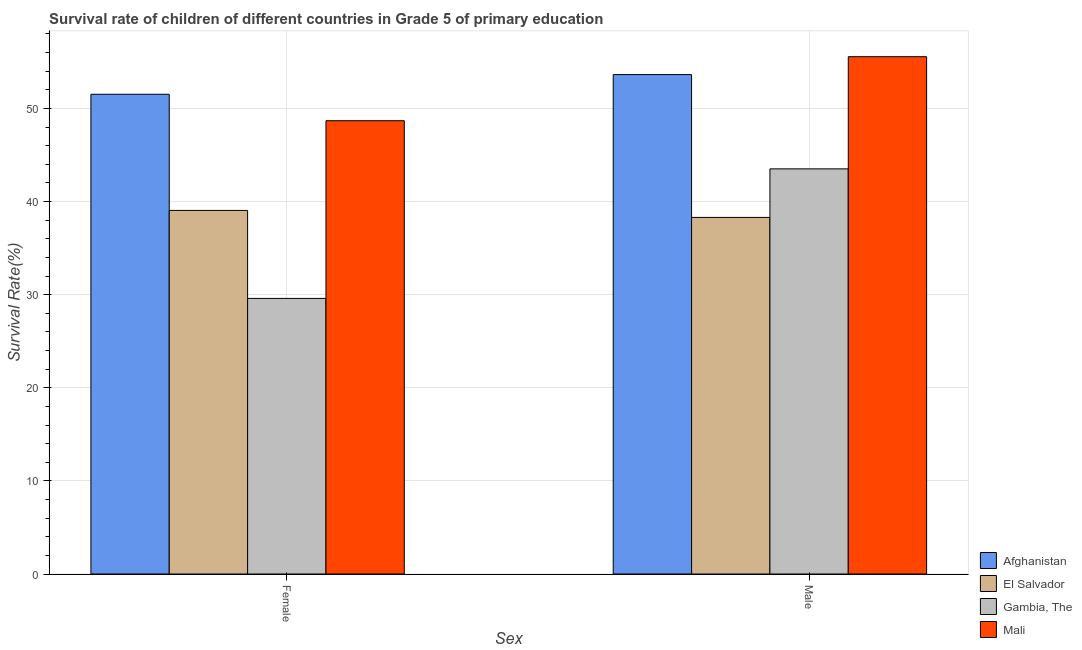Are the number of bars per tick equal to the number of legend labels?
Offer a terse response. Yes. Are the number of bars on each tick of the X-axis equal?
Keep it short and to the point. Yes. How many bars are there on the 2nd tick from the left?
Your answer should be very brief. 4. How many bars are there on the 2nd tick from the right?
Your answer should be very brief. 4. What is the survival rate of female students in primary education in Gambia, The?
Provide a short and direct response. 29.6. Across all countries, what is the maximum survival rate of female students in primary education?
Your answer should be very brief. 51.52. Across all countries, what is the minimum survival rate of female students in primary education?
Ensure brevity in your answer.  29.6. In which country was the survival rate of male students in primary education maximum?
Your answer should be very brief. Mali. In which country was the survival rate of male students in primary education minimum?
Provide a succinct answer. El Salvador. What is the total survival rate of male students in primary education in the graph?
Provide a short and direct response. 190.99. What is the difference between the survival rate of male students in primary education in El Salvador and that in Gambia, The?
Provide a succinct answer. -5.21. What is the difference between the survival rate of male students in primary education in El Salvador and the survival rate of female students in primary education in Gambia, The?
Your answer should be compact. 8.7. What is the average survival rate of male students in primary education per country?
Offer a terse response. 47.75. What is the difference between the survival rate of female students in primary education and survival rate of male students in primary education in Afghanistan?
Make the answer very short. -2.12. In how many countries, is the survival rate of female students in primary education greater than 6 %?
Offer a very short reply. 4. What is the ratio of the survival rate of male students in primary education in El Salvador to that in Afghanistan?
Your answer should be very brief. 0.71. Is the survival rate of female students in primary education in Afghanistan less than that in Gambia, The?
Provide a succinct answer. No. In how many countries, is the survival rate of male students in primary education greater than the average survival rate of male students in primary education taken over all countries?
Your answer should be compact. 2. What does the 2nd bar from the left in Female represents?
Provide a short and direct response. El Salvador. What does the 1st bar from the right in Female represents?
Offer a terse response. Mali. How many countries are there in the graph?
Keep it short and to the point. 4. How many legend labels are there?
Give a very brief answer. 4. How are the legend labels stacked?
Provide a short and direct response. Vertical. What is the title of the graph?
Offer a terse response. Survival rate of children of different countries in Grade 5 of primary education. What is the label or title of the X-axis?
Provide a short and direct response. Sex. What is the label or title of the Y-axis?
Provide a succinct answer. Survival Rate(%). What is the Survival Rate(%) in Afghanistan in Female?
Provide a short and direct response. 51.52. What is the Survival Rate(%) of El Salvador in Female?
Your response must be concise. 39.04. What is the Survival Rate(%) in Gambia, The in Female?
Make the answer very short. 29.6. What is the Survival Rate(%) of Mali in Female?
Give a very brief answer. 48.68. What is the Survival Rate(%) in Afghanistan in Male?
Your answer should be compact. 53.63. What is the Survival Rate(%) of El Salvador in Male?
Offer a very short reply. 38.29. What is the Survival Rate(%) of Gambia, The in Male?
Ensure brevity in your answer.  43.51. What is the Survival Rate(%) in Mali in Male?
Your answer should be very brief. 55.55. Across all Sex, what is the maximum Survival Rate(%) in Afghanistan?
Your response must be concise. 53.63. Across all Sex, what is the maximum Survival Rate(%) of El Salvador?
Your answer should be compact. 39.04. Across all Sex, what is the maximum Survival Rate(%) of Gambia, The?
Ensure brevity in your answer.  43.51. Across all Sex, what is the maximum Survival Rate(%) of Mali?
Offer a very short reply. 55.55. Across all Sex, what is the minimum Survival Rate(%) in Afghanistan?
Provide a succinct answer. 51.52. Across all Sex, what is the minimum Survival Rate(%) in El Salvador?
Your response must be concise. 38.29. Across all Sex, what is the minimum Survival Rate(%) in Gambia, The?
Give a very brief answer. 29.6. Across all Sex, what is the minimum Survival Rate(%) in Mali?
Your response must be concise. 48.68. What is the total Survival Rate(%) in Afghanistan in the graph?
Give a very brief answer. 105.15. What is the total Survival Rate(%) of El Salvador in the graph?
Give a very brief answer. 77.34. What is the total Survival Rate(%) of Gambia, The in the graph?
Keep it short and to the point. 73.1. What is the total Survival Rate(%) of Mali in the graph?
Provide a succinct answer. 104.23. What is the difference between the Survival Rate(%) of Afghanistan in Female and that in Male?
Provide a short and direct response. -2.12. What is the difference between the Survival Rate(%) of El Salvador in Female and that in Male?
Keep it short and to the point. 0.75. What is the difference between the Survival Rate(%) of Gambia, The in Female and that in Male?
Give a very brief answer. -13.91. What is the difference between the Survival Rate(%) of Mali in Female and that in Male?
Provide a short and direct response. -6.88. What is the difference between the Survival Rate(%) in Afghanistan in Female and the Survival Rate(%) in El Salvador in Male?
Keep it short and to the point. 13.22. What is the difference between the Survival Rate(%) of Afghanistan in Female and the Survival Rate(%) of Gambia, The in Male?
Ensure brevity in your answer.  8.01. What is the difference between the Survival Rate(%) in Afghanistan in Female and the Survival Rate(%) in Mali in Male?
Your answer should be very brief. -4.04. What is the difference between the Survival Rate(%) of El Salvador in Female and the Survival Rate(%) of Gambia, The in Male?
Make the answer very short. -4.46. What is the difference between the Survival Rate(%) of El Salvador in Female and the Survival Rate(%) of Mali in Male?
Make the answer very short. -16.51. What is the difference between the Survival Rate(%) in Gambia, The in Female and the Survival Rate(%) in Mali in Male?
Offer a very short reply. -25.96. What is the average Survival Rate(%) of Afghanistan per Sex?
Provide a short and direct response. 52.58. What is the average Survival Rate(%) of El Salvador per Sex?
Your response must be concise. 38.67. What is the average Survival Rate(%) in Gambia, The per Sex?
Your answer should be compact. 36.55. What is the average Survival Rate(%) in Mali per Sex?
Give a very brief answer. 52.12. What is the difference between the Survival Rate(%) of Afghanistan and Survival Rate(%) of El Salvador in Female?
Ensure brevity in your answer.  12.47. What is the difference between the Survival Rate(%) in Afghanistan and Survival Rate(%) in Gambia, The in Female?
Your answer should be compact. 21.92. What is the difference between the Survival Rate(%) in Afghanistan and Survival Rate(%) in Mali in Female?
Your response must be concise. 2.84. What is the difference between the Survival Rate(%) in El Salvador and Survival Rate(%) in Gambia, The in Female?
Your response must be concise. 9.45. What is the difference between the Survival Rate(%) in El Salvador and Survival Rate(%) in Mali in Female?
Your response must be concise. -9.63. What is the difference between the Survival Rate(%) in Gambia, The and Survival Rate(%) in Mali in Female?
Your answer should be very brief. -19.08. What is the difference between the Survival Rate(%) of Afghanistan and Survival Rate(%) of El Salvador in Male?
Offer a very short reply. 15.34. What is the difference between the Survival Rate(%) of Afghanistan and Survival Rate(%) of Gambia, The in Male?
Your response must be concise. 10.13. What is the difference between the Survival Rate(%) in Afghanistan and Survival Rate(%) in Mali in Male?
Keep it short and to the point. -1.92. What is the difference between the Survival Rate(%) of El Salvador and Survival Rate(%) of Gambia, The in Male?
Give a very brief answer. -5.21. What is the difference between the Survival Rate(%) in El Salvador and Survival Rate(%) in Mali in Male?
Your answer should be compact. -17.26. What is the difference between the Survival Rate(%) of Gambia, The and Survival Rate(%) of Mali in Male?
Your answer should be compact. -12.05. What is the ratio of the Survival Rate(%) in Afghanistan in Female to that in Male?
Give a very brief answer. 0.96. What is the ratio of the Survival Rate(%) in El Salvador in Female to that in Male?
Keep it short and to the point. 1.02. What is the ratio of the Survival Rate(%) of Gambia, The in Female to that in Male?
Give a very brief answer. 0.68. What is the ratio of the Survival Rate(%) of Mali in Female to that in Male?
Give a very brief answer. 0.88. What is the difference between the highest and the second highest Survival Rate(%) of Afghanistan?
Give a very brief answer. 2.12. What is the difference between the highest and the second highest Survival Rate(%) in El Salvador?
Offer a terse response. 0.75. What is the difference between the highest and the second highest Survival Rate(%) in Gambia, The?
Provide a succinct answer. 13.91. What is the difference between the highest and the second highest Survival Rate(%) in Mali?
Offer a very short reply. 6.88. What is the difference between the highest and the lowest Survival Rate(%) of Afghanistan?
Your answer should be compact. 2.12. What is the difference between the highest and the lowest Survival Rate(%) of El Salvador?
Provide a succinct answer. 0.75. What is the difference between the highest and the lowest Survival Rate(%) in Gambia, The?
Provide a succinct answer. 13.91. What is the difference between the highest and the lowest Survival Rate(%) in Mali?
Your answer should be very brief. 6.88. 